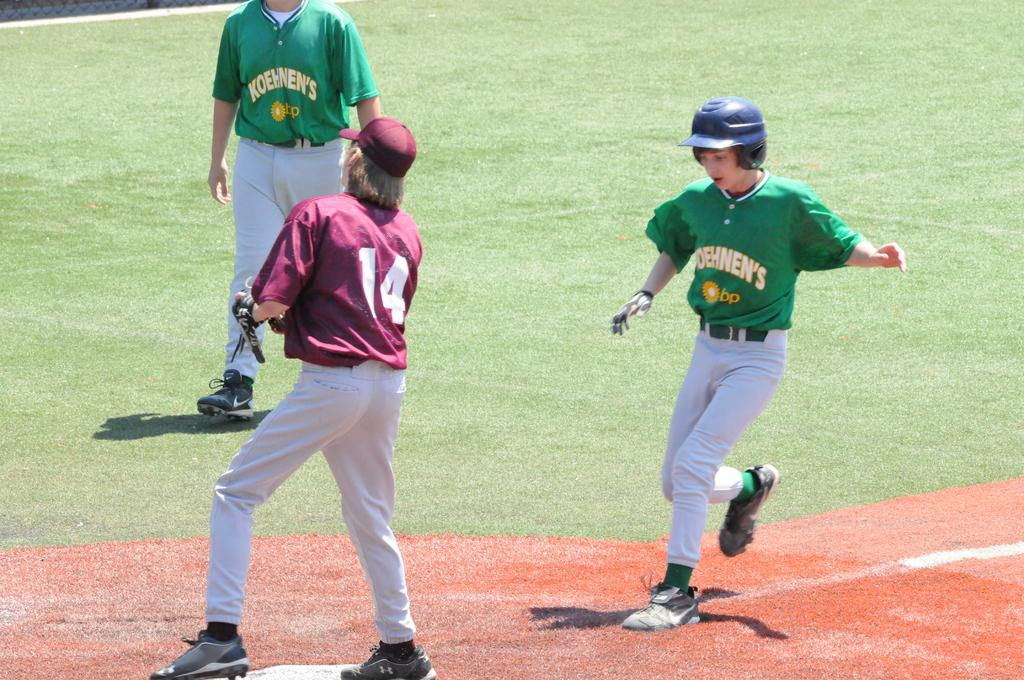<image>
Render a clear and concise summary of the photo. A baseball catcher wearing number 14 prepares to catch as a runner closes on base. 